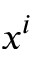Convert formula to latex. <formula><loc_0><loc_0><loc_500><loc_500>x ^ { i }</formula> 